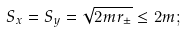Convert formula to latex. <formula><loc_0><loc_0><loc_500><loc_500>S _ { x } = S _ { y } = \sqrt { 2 m r _ { \pm } } \leq 2 m ;</formula> 